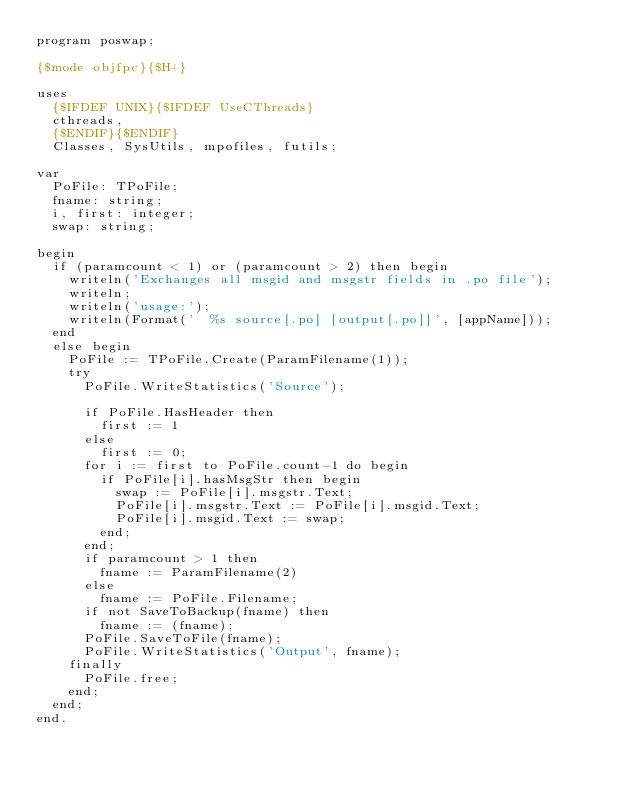Convert code to text. <code><loc_0><loc_0><loc_500><loc_500><_Pascal_>program poswap;

{$mode objfpc}{$H+}

uses
  {$IFDEF UNIX}{$IFDEF UseCThreads}
  cthreads,
  {$ENDIF}{$ENDIF}
  Classes, SysUtils, mpofiles, futils;

var
  PoFile: TPoFile;
  fname: string;
  i, first: integer;
  swap: string;

begin
  if (paramcount < 1) or (paramcount > 2) then begin
    writeln('Exchanges all msgid and msgstr fields in .po file');
    writeln;
    writeln('usage:');
    writeln(Format('  %s source[.po] [output[.po]]', [appName]));
  end
  else begin
    PoFile := TPoFile.Create(ParamFilename(1));
    try
      PoFile.WriteStatistics('Source');

      if PoFile.HasHeader then
        first := 1
      else
        first := 0;
      for i := first to PoFile.count-1 do begin
        if PoFile[i].hasMsgStr then begin
          swap := PoFile[i].msgstr.Text;
          PoFile[i].msgstr.Text := PoFile[i].msgid.Text;
          PoFile[i].msgid.Text := swap;
        end;
      end;
      if paramcount > 1 then
        fname := ParamFilename(2)
      else
        fname := PoFile.Filename;
      if not SaveToBackup(fname) then
        fname := (fname);
      PoFile.SaveToFile(fname);
      PoFile.WriteStatistics('Output', fname);
    finally
      PoFile.free;
    end;
  end;
end.

</code> 